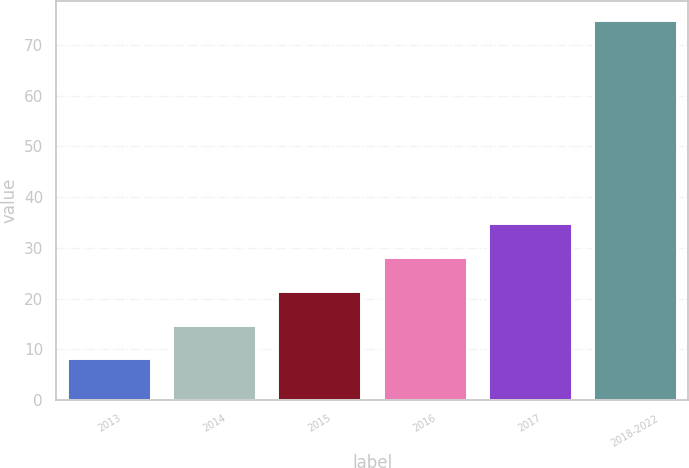Convert chart. <chart><loc_0><loc_0><loc_500><loc_500><bar_chart><fcel>2013<fcel>2014<fcel>2015<fcel>2016<fcel>2017<fcel>2018-2022<nl><fcel>8.2<fcel>14.87<fcel>21.54<fcel>28.21<fcel>34.88<fcel>74.9<nl></chart> 